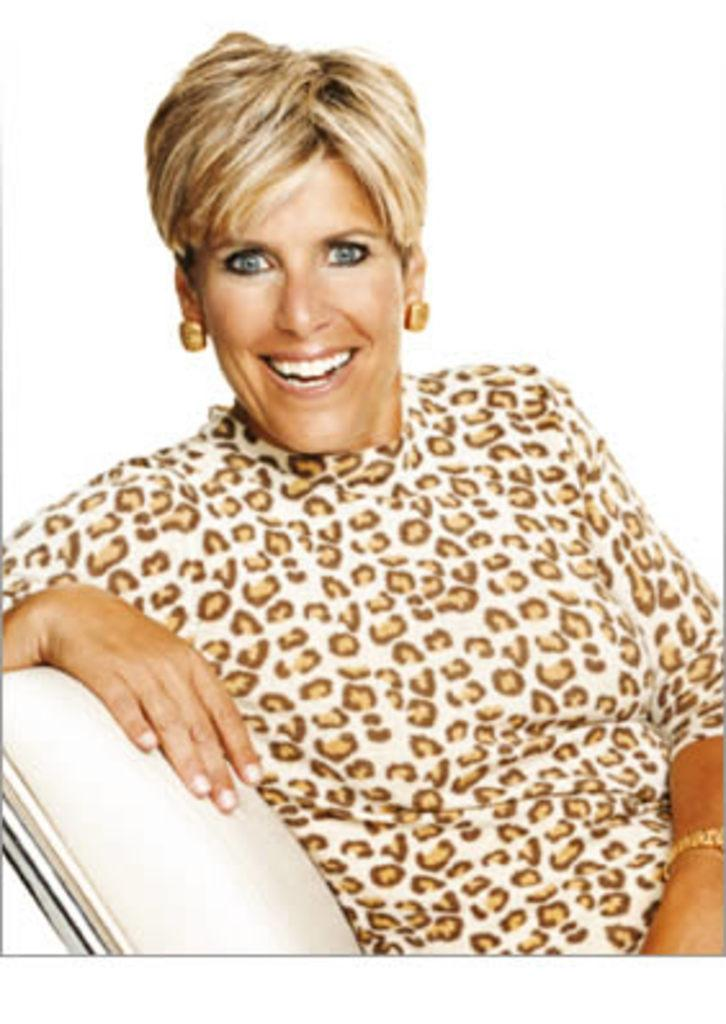Who is present in the image? There are women in the image. What are the women wearing? The women are wearing white and gold color dresses. What are the women doing in the image? The women are sitting on a chair. What type of property can be seen in the background of the image? There is no property visible in the background of the image. Can you tell me how many faces are present in the image? There are no faces present in the image; it only shows the women's bodies and dresses. 